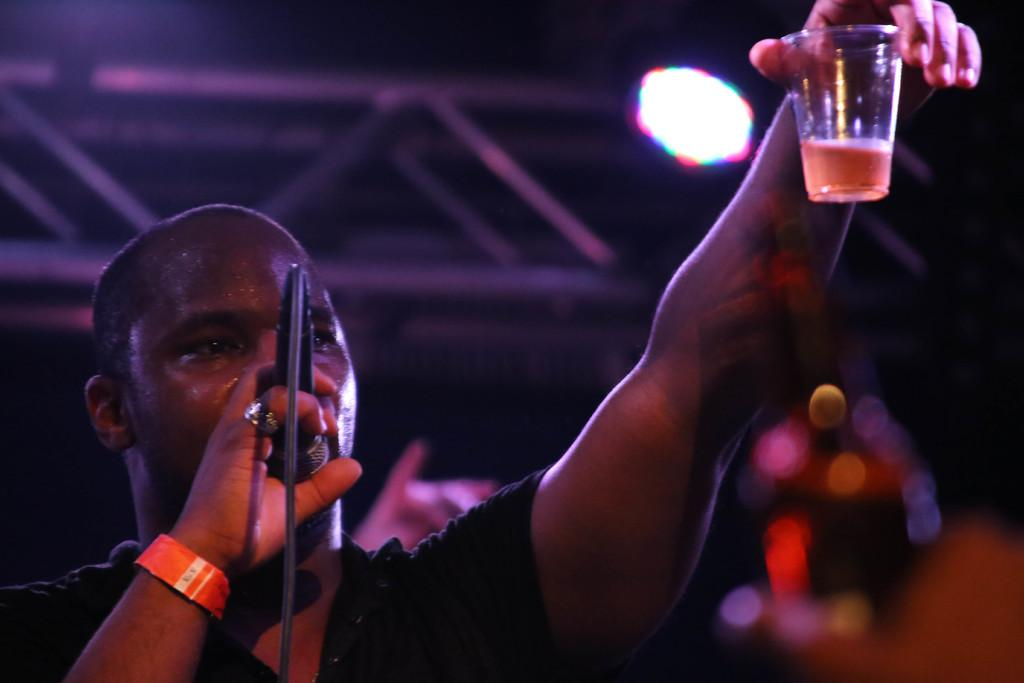Who is present in the image? There is a man in the image. What is the man holding in his hands? The man is holding a cup and a mic. What can be seen in the background of the image? There is light in the background of the image. How many chairs are visible in the image? There are no chairs visible in the image. What type of income does the man in the image have? There is no information about the man's income in the image. 